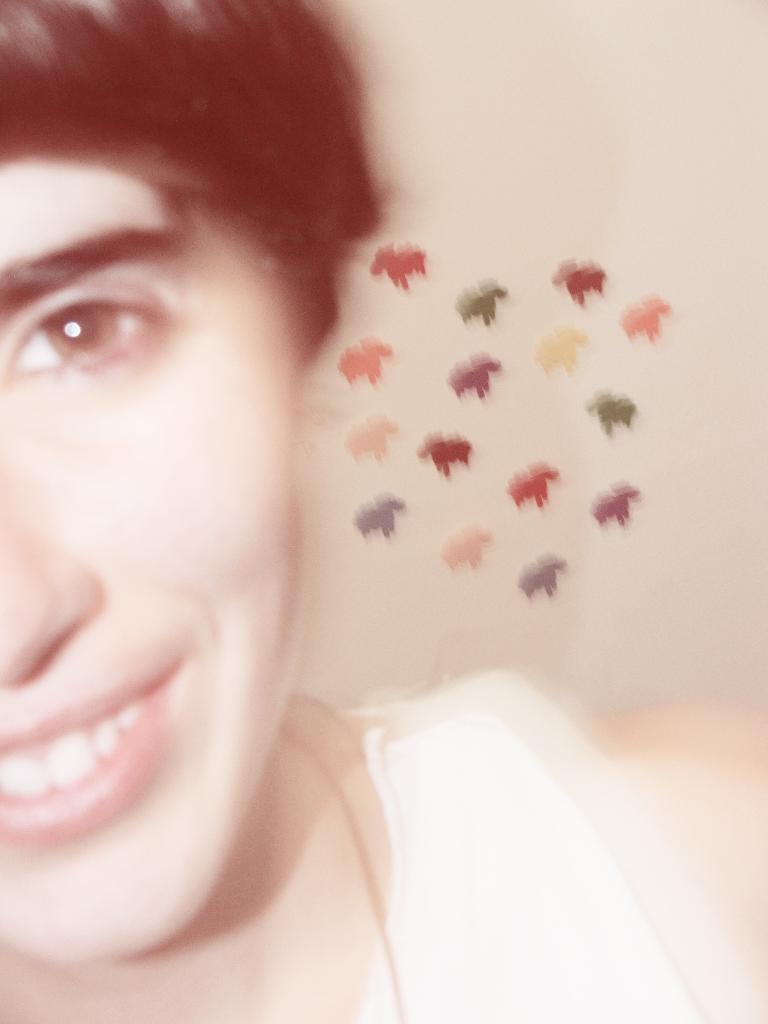Can you describe this image briefly? In this image, we can see a person and we can see some stickers like objects on the wall. 